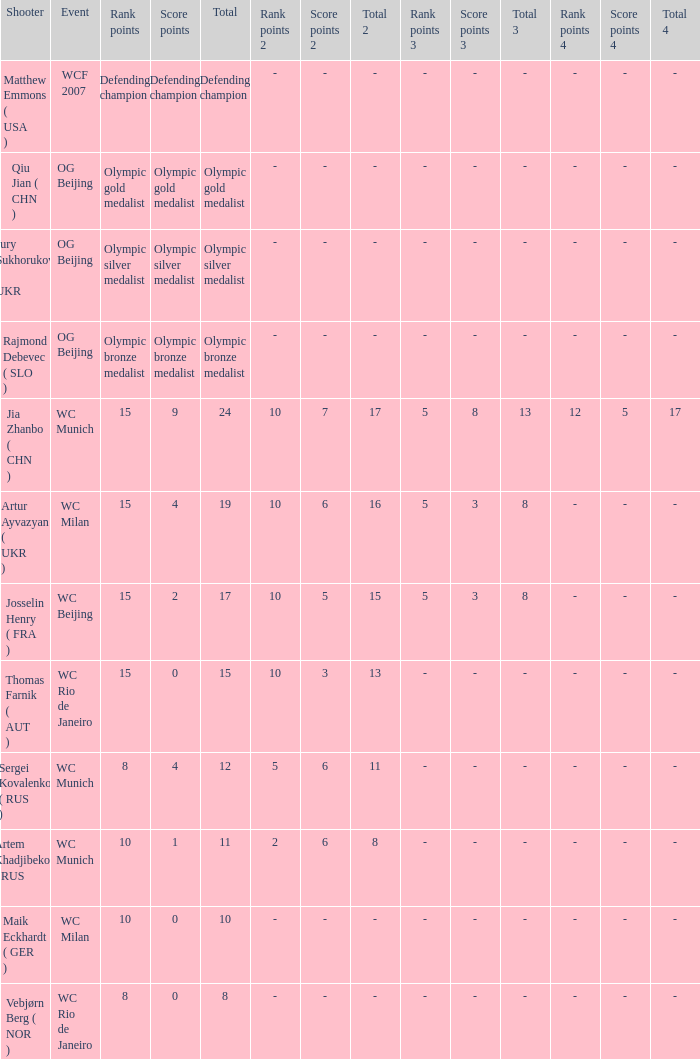Who is the shooter with 15 rank points, and 0 score points? Thomas Farnik ( AUT ). 